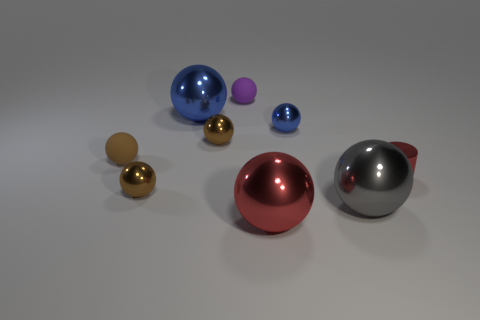How many brown balls must be subtracted to get 1 brown balls? 2 Subtract all brown rubber balls. How many balls are left? 7 Add 1 tiny rubber objects. How many objects exist? 10 Subtract 1 cylinders. How many cylinders are left? 0 Subtract all purple balls. How many balls are left? 7 Subtract all cylinders. How many objects are left? 8 Add 7 small red metal things. How many small red metal things exist? 8 Subtract 0 purple cylinders. How many objects are left? 9 Subtract all yellow cylinders. Subtract all red balls. How many cylinders are left? 1 Subtract all yellow cylinders. How many brown balls are left? 3 